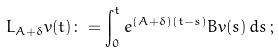<formula> <loc_0><loc_0><loc_500><loc_500>L _ { A + \delta } v ( t ) \colon = \int _ { 0 } ^ { t } e ^ { ( A + \delta ) ( t - s ) } B v ( s ) \, d s \, ;</formula> 